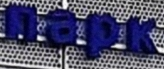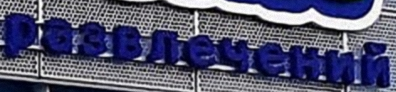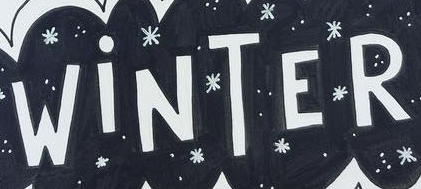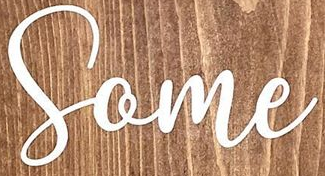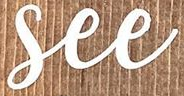What words can you see in these images in sequence, separated by a semicolon? пapk; paзвлeчeний; WiNTER; Some; See 